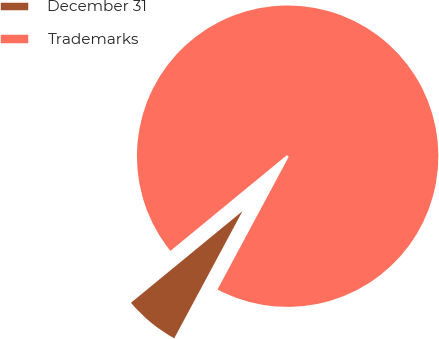Convert chart to OTSL. <chart><loc_0><loc_0><loc_500><loc_500><pie_chart><fcel>December 31<fcel>Trademarks<nl><fcel>6.21%<fcel>93.79%<nl></chart> 